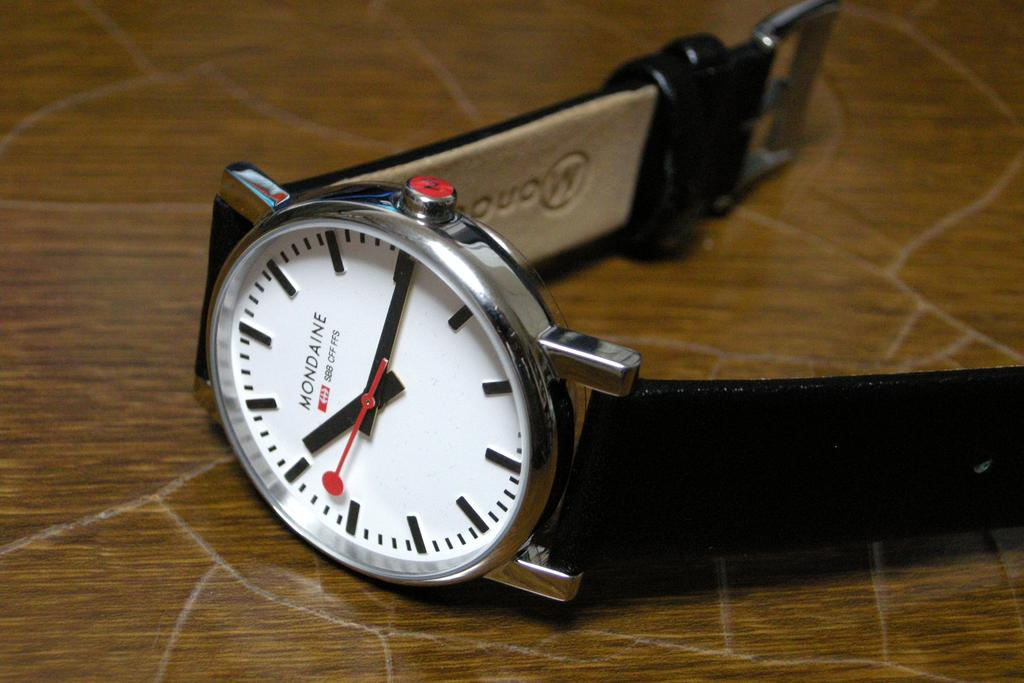Provide a one-sentence caption for the provided image. A Mondaine watch with a black ban and and white face showing the time of 10:15. 